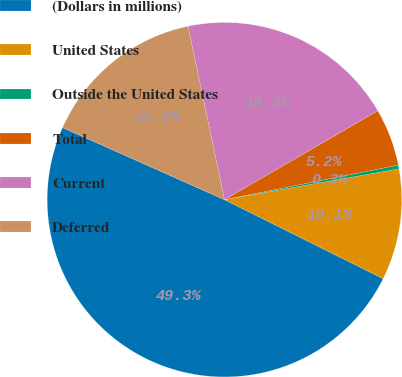<chart> <loc_0><loc_0><loc_500><loc_500><pie_chart><fcel>(Dollars in millions)<fcel>United States<fcel>Outside the United States<fcel>Total<fcel>Current<fcel>Deferred<nl><fcel>49.31%<fcel>10.14%<fcel>0.34%<fcel>5.24%<fcel>19.93%<fcel>15.03%<nl></chart> 